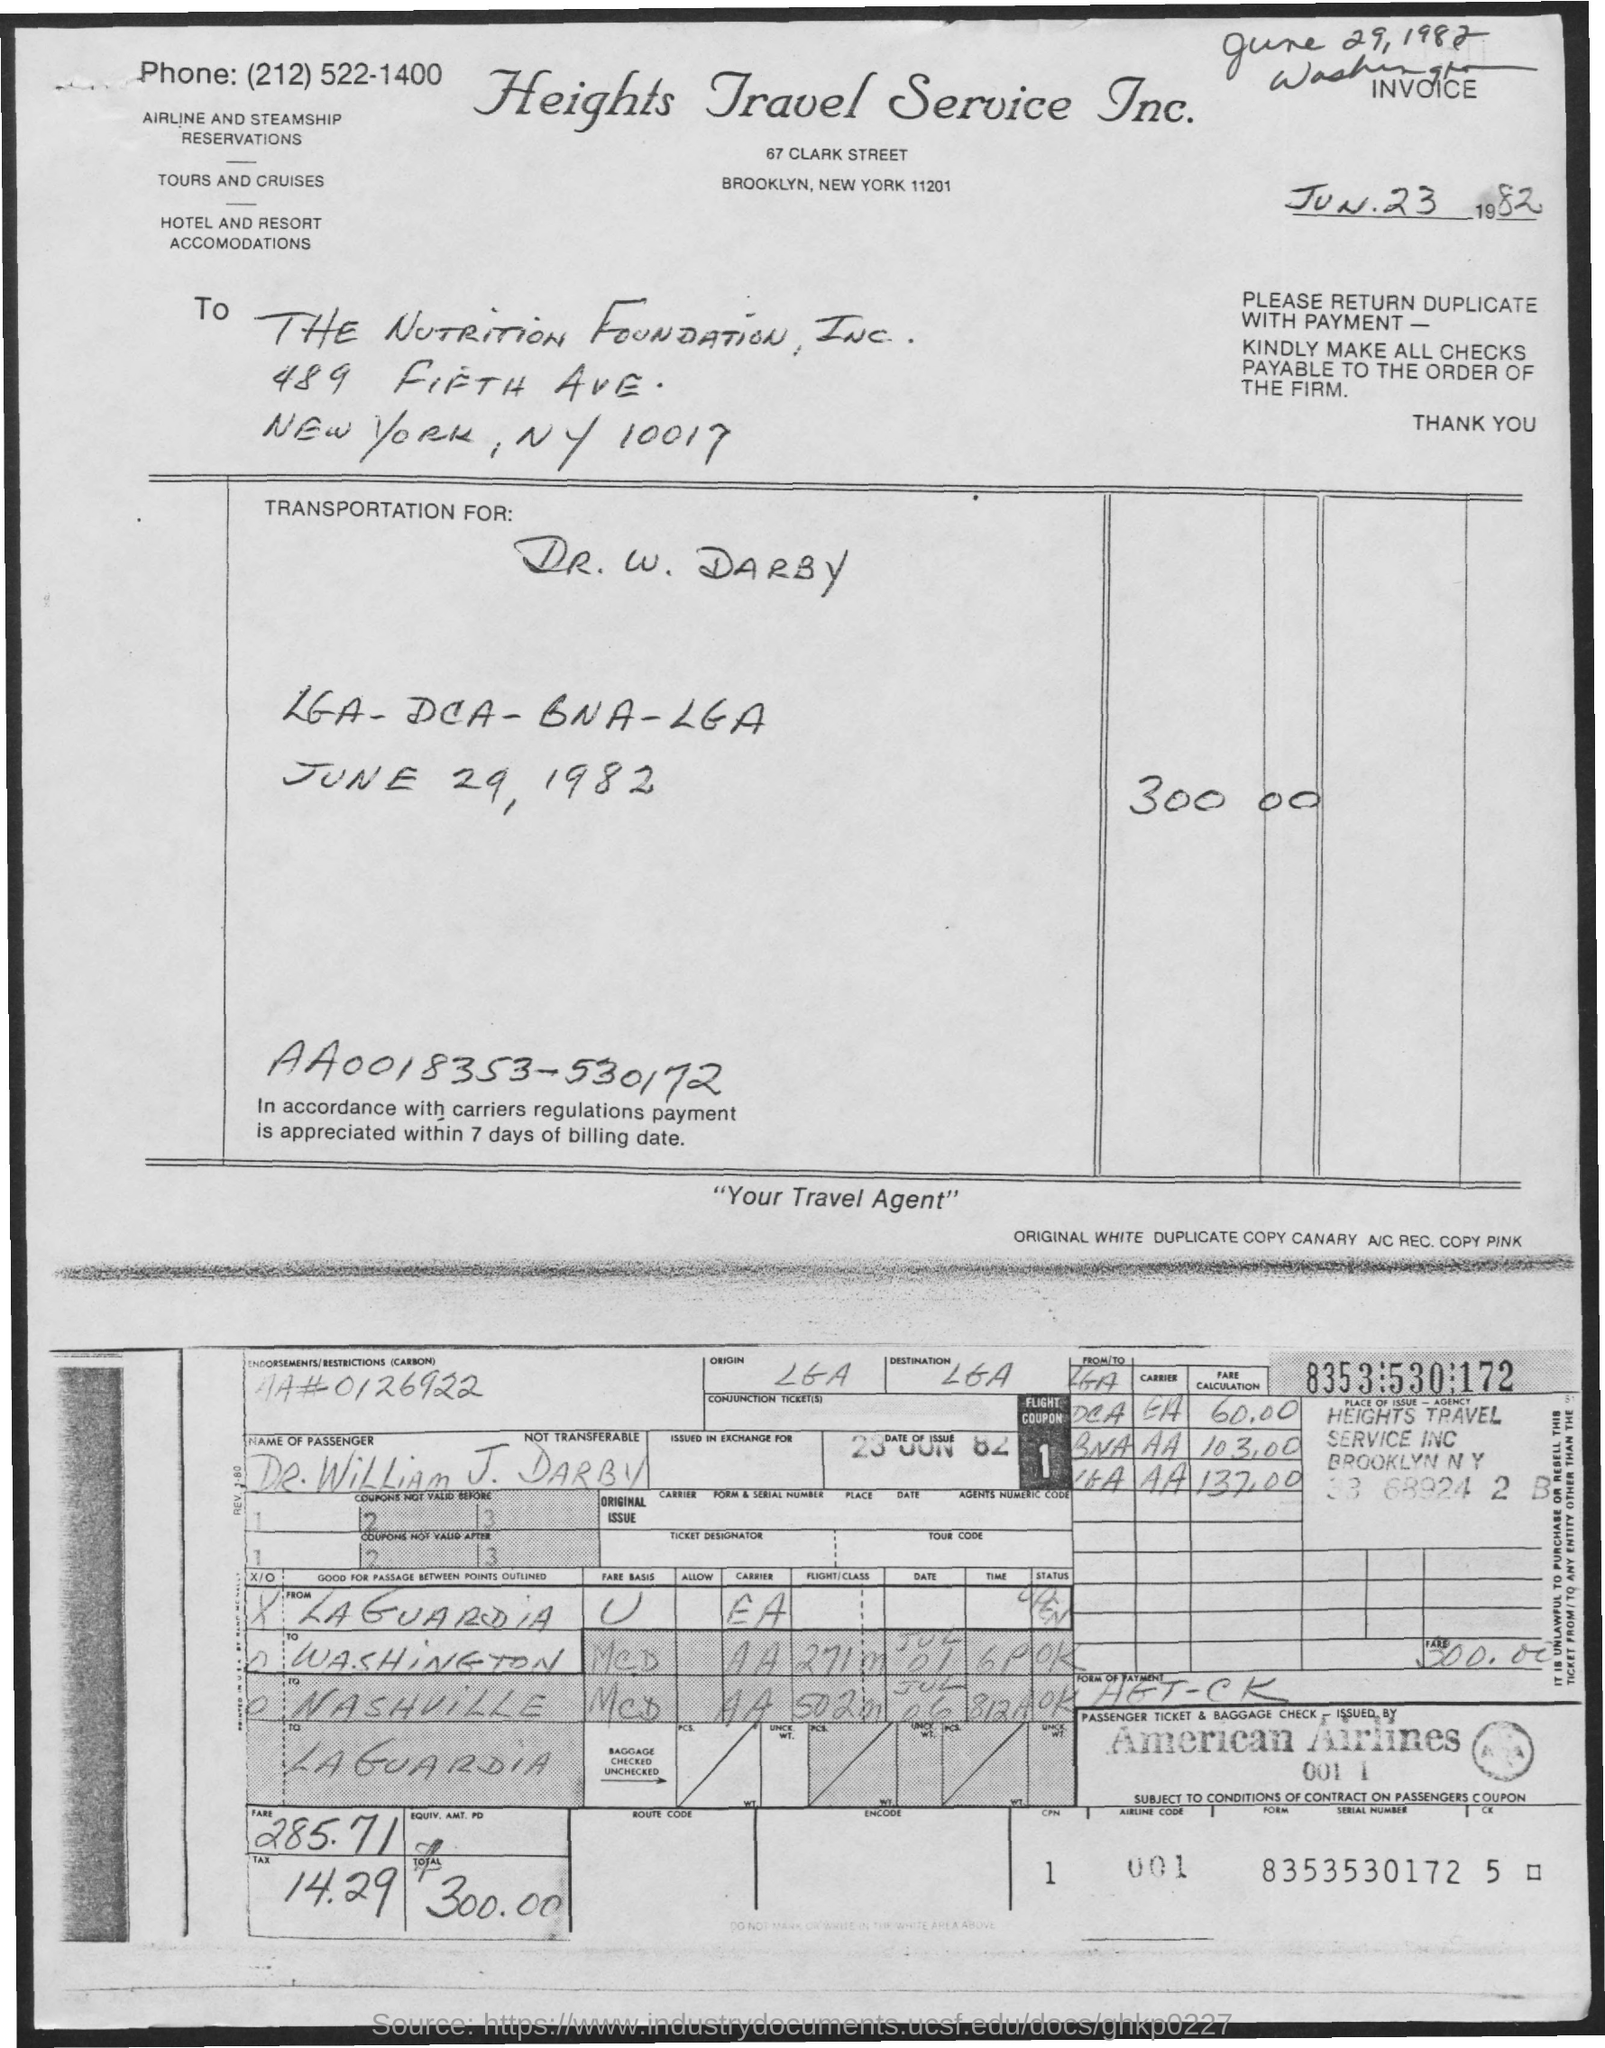What locations are mentioned in the travel itinerary? The travel itinerary mentions flights from LaGuardia Airport (LGA) in New York to Ronald Reagan Washington National Airport (DCA) in Washington, D.C., and then to Nashville (BNA) and back to LaGuardia. What date is the travel scheduled? The travel was scheduled for June 29, 1982, according to the document. 